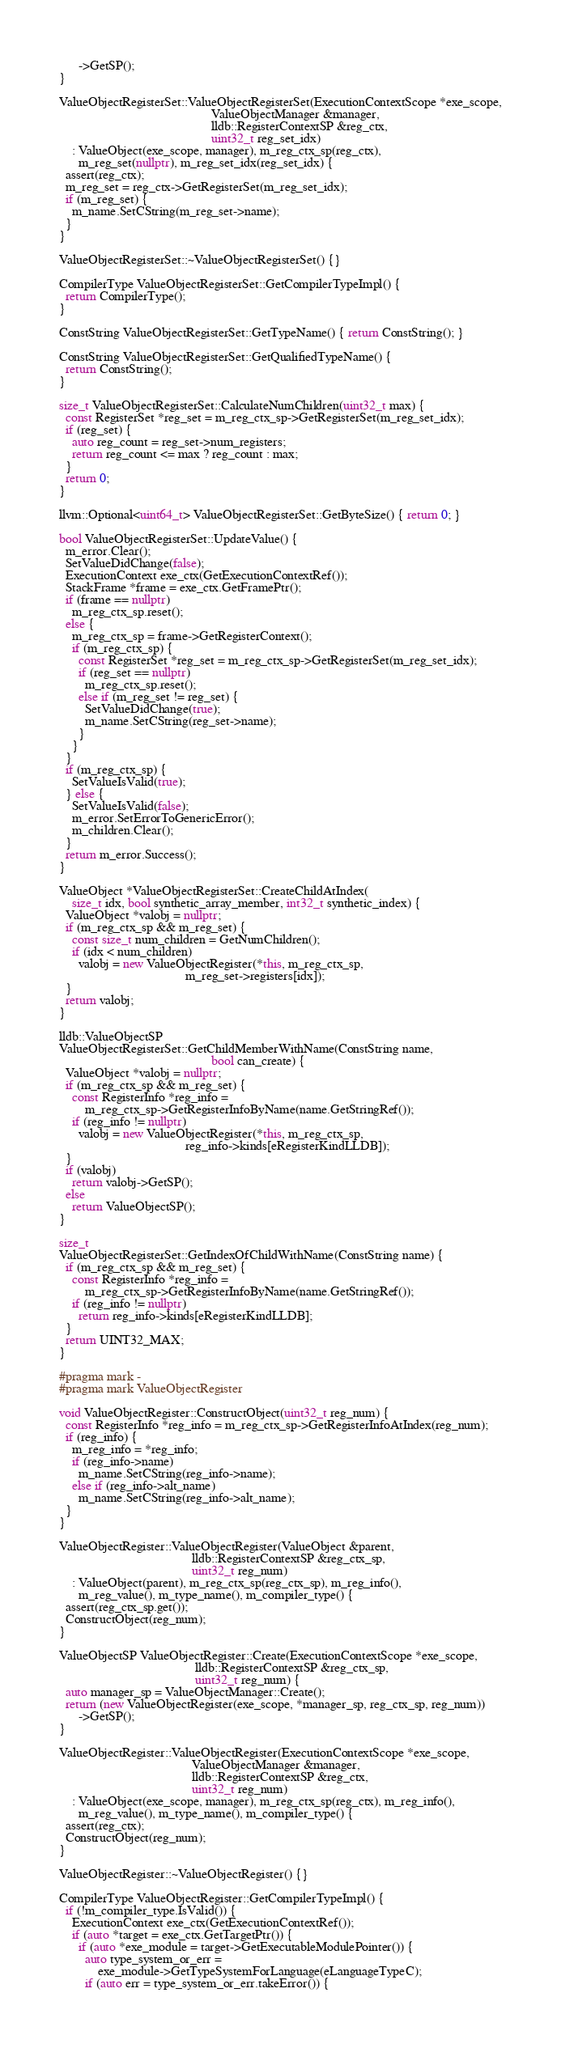<code> <loc_0><loc_0><loc_500><loc_500><_C++_>      ->GetSP();
}

ValueObjectRegisterSet::ValueObjectRegisterSet(ExecutionContextScope *exe_scope,
                                               ValueObjectManager &manager,
                                               lldb::RegisterContextSP &reg_ctx,
                                               uint32_t reg_set_idx)
    : ValueObject(exe_scope, manager), m_reg_ctx_sp(reg_ctx),
      m_reg_set(nullptr), m_reg_set_idx(reg_set_idx) {
  assert(reg_ctx);
  m_reg_set = reg_ctx->GetRegisterSet(m_reg_set_idx);
  if (m_reg_set) {
    m_name.SetCString(m_reg_set->name);
  }
}

ValueObjectRegisterSet::~ValueObjectRegisterSet() {}

CompilerType ValueObjectRegisterSet::GetCompilerTypeImpl() {
  return CompilerType();
}

ConstString ValueObjectRegisterSet::GetTypeName() { return ConstString(); }

ConstString ValueObjectRegisterSet::GetQualifiedTypeName() {
  return ConstString();
}

size_t ValueObjectRegisterSet::CalculateNumChildren(uint32_t max) {
  const RegisterSet *reg_set = m_reg_ctx_sp->GetRegisterSet(m_reg_set_idx);
  if (reg_set) {
    auto reg_count = reg_set->num_registers;
    return reg_count <= max ? reg_count : max;
  }
  return 0;
}

llvm::Optional<uint64_t> ValueObjectRegisterSet::GetByteSize() { return 0; }

bool ValueObjectRegisterSet::UpdateValue() {
  m_error.Clear();
  SetValueDidChange(false);
  ExecutionContext exe_ctx(GetExecutionContextRef());
  StackFrame *frame = exe_ctx.GetFramePtr();
  if (frame == nullptr)
    m_reg_ctx_sp.reset();
  else {
    m_reg_ctx_sp = frame->GetRegisterContext();
    if (m_reg_ctx_sp) {
      const RegisterSet *reg_set = m_reg_ctx_sp->GetRegisterSet(m_reg_set_idx);
      if (reg_set == nullptr)
        m_reg_ctx_sp.reset();
      else if (m_reg_set != reg_set) {
        SetValueDidChange(true);
        m_name.SetCString(reg_set->name);
      }
    }
  }
  if (m_reg_ctx_sp) {
    SetValueIsValid(true);
  } else {
    SetValueIsValid(false);
    m_error.SetErrorToGenericError();
    m_children.Clear();
  }
  return m_error.Success();
}

ValueObject *ValueObjectRegisterSet::CreateChildAtIndex(
    size_t idx, bool synthetic_array_member, int32_t synthetic_index) {
  ValueObject *valobj = nullptr;
  if (m_reg_ctx_sp && m_reg_set) {
    const size_t num_children = GetNumChildren();
    if (idx < num_children)
      valobj = new ValueObjectRegister(*this, m_reg_ctx_sp,
                                       m_reg_set->registers[idx]);
  }
  return valobj;
}

lldb::ValueObjectSP
ValueObjectRegisterSet::GetChildMemberWithName(ConstString name,
                                               bool can_create) {
  ValueObject *valobj = nullptr;
  if (m_reg_ctx_sp && m_reg_set) {
    const RegisterInfo *reg_info =
        m_reg_ctx_sp->GetRegisterInfoByName(name.GetStringRef());
    if (reg_info != nullptr)
      valobj = new ValueObjectRegister(*this, m_reg_ctx_sp,
                                       reg_info->kinds[eRegisterKindLLDB]);
  }
  if (valobj)
    return valobj->GetSP();
  else
    return ValueObjectSP();
}

size_t
ValueObjectRegisterSet::GetIndexOfChildWithName(ConstString name) {
  if (m_reg_ctx_sp && m_reg_set) {
    const RegisterInfo *reg_info =
        m_reg_ctx_sp->GetRegisterInfoByName(name.GetStringRef());
    if (reg_info != nullptr)
      return reg_info->kinds[eRegisterKindLLDB];
  }
  return UINT32_MAX;
}

#pragma mark -
#pragma mark ValueObjectRegister

void ValueObjectRegister::ConstructObject(uint32_t reg_num) {
  const RegisterInfo *reg_info = m_reg_ctx_sp->GetRegisterInfoAtIndex(reg_num);
  if (reg_info) {
    m_reg_info = *reg_info;
    if (reg_info->name)
      m_name.SetCString(reg_info->name);
    else if (reg_info->alt_name)
      m_name.SetCString(reg_info->alt_name);
  }
}

ValueObjectRegister::ValueObjectRegister(ValueObject &parent,
                                         lldb::RegisterContextSP &reg_ctx_sp,
                                         uint32_t reg_num)
    : ValueObject(parent), m_reg_ctx_sp(reg_ctx_sp), m_reg_info(),
      m_reg_value(), m_type_name(), m_compiler_type() {
  assert(reg_ctx_sp.get());
  ConstructObject(reg_num);
}

ValueObjectSP ValueObjectRegister::Create(ExecutionContextScope *exe_scope,
                                          lldb::RegisterContextSP &reg_ctx_sp,
                                          uint32_t reg_num) {
  auto manager_sp = ValueObjectManager::Create();
  return (new ValueObjectRegister(exe_scope, *manager_sp, reg_ctx_sp, reg_num))
      ->GetSP();
}

ValueObjectRegister::ValueObjectRegister(ExecutionContextScope *exe_scope,
                                         ValueObjectManager &manager,
                                         lldb::RegisterContextSP &reg_ctx,
                                         uint32_t reg_num)
    : ValueObject(exe_scope, manager), m_reg_ctx_sp(reg_ctx), m_reg_info(),
      m_reg_value(), m_type_name(), m_compiler_type() {
  assert(reg_ctx);
  ConstructObject(reg_num);
}

ValueObjectRegister::~ValueObjectRegister() {}

CompilerType ValueObjectRegister::GetCompilerTypeImpl() {
  if (!m_compiler_type.IsValid()) {
    ExecutionContext exe_ctx(GetExecutionContextRef());
    if (auto *target = exe_ctx.GetTargetPtr()) {
      if (auto *exe_module = target->GetExecutableModulePointer()) {
        auto type_system_or_err =
            exe_module->GetTypeSystemForLanguage(eLanguageTypeC);
        if (auto err = type_system_or_err.takeError()) {</code> 